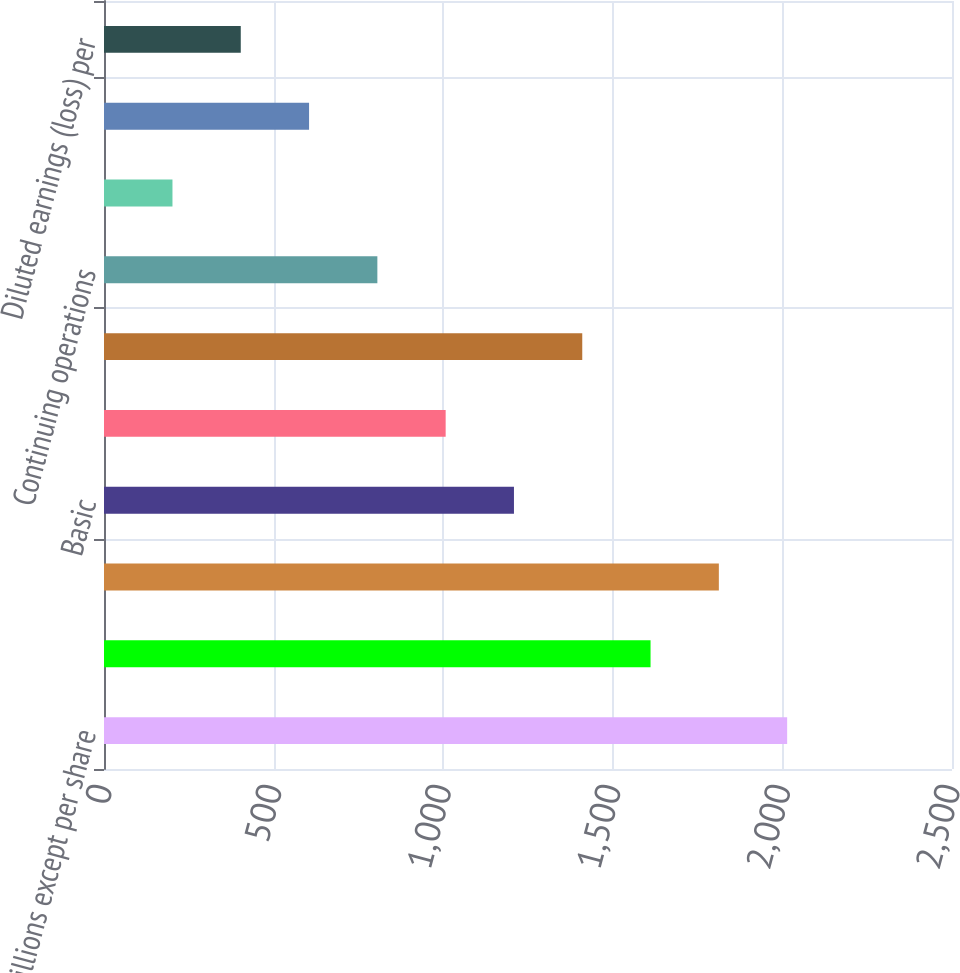Convert chart. <chart><loc_0><loc_0><loc_500><loc_500><bar_chart><fcel>In millions except per share<fcel>Net income (loss)<fcel>Net income from continuing<fcel>Basic<fcel>Dilutive impact of stock<fcel>Diluted<fcel>Continuing operations<fcel>Discontinued operations<fcel>Basic earnings (loss) per<fcel>Diluted earnings (loss) per<nl><fcel>2014<fcel>1611.3<fcel>1812.65<fcel>1208.6<fcel>1007.25<fcel>1409.95<fcel>805.9<fcel>201.85<fcel>604.55<fcel>403.2<nl></chart> 